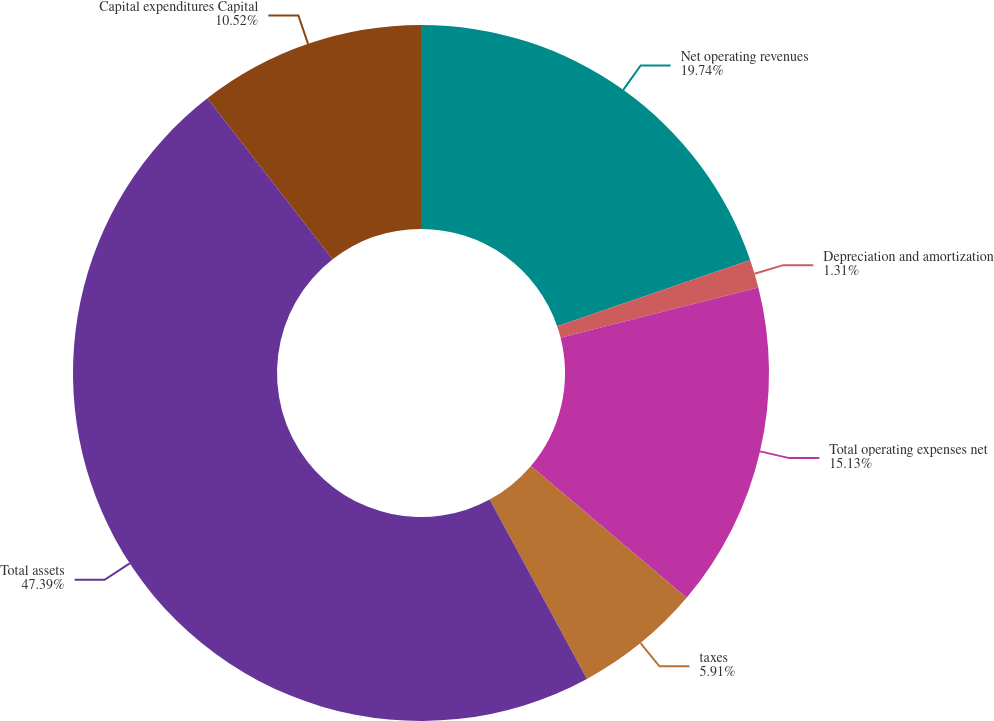<chart> <loc_0><loc_0><loc_500><loc_500><pie_chart><fcel>Net operating revenues<fcel>Depreciation and amortization<fcel>Total operating expenses net<fcel>taxes<fcel>Total assets<fcel>Capital expenditures Capital<nl><fcel>19.74%<fcel>1.31%<fcel>15.13%<fcel>5.91%<fcel>47.39%<fcel>10.52%<nl></chart> 